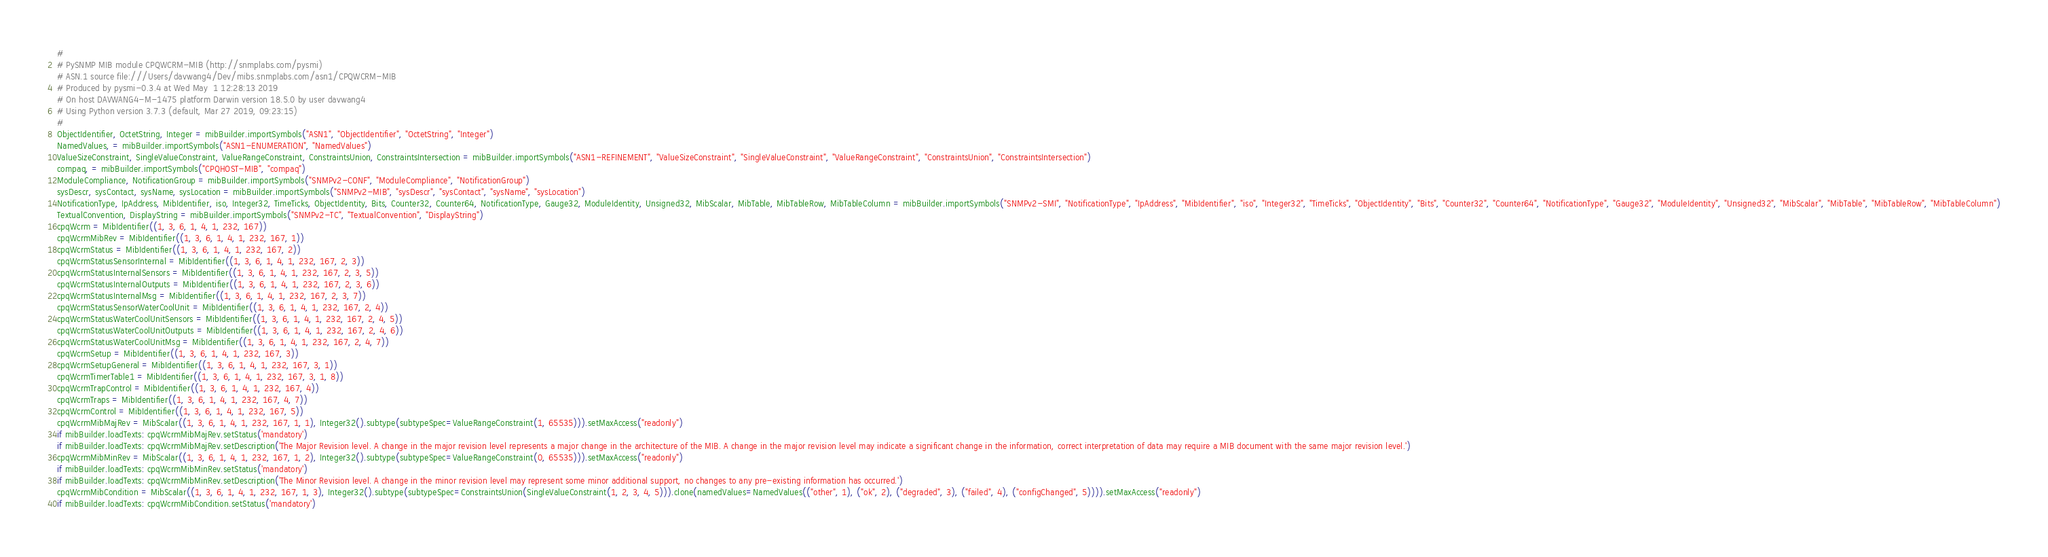<code> <loc_0><loc_0><loc_500><loc_500><_Python_>#
# PySNMP MIB module CPQWCRM-MIB (http://snmplabs.com/pysmi)
# ASN.1 source file:///Users/davwang4/Dev/mibs.snmplabs.com/asn1/CPQWCRM-MIB
# Produced by pysmi-0.3.4 at Wed May  1 12:28:13 2019
# On host DAVWANG4-M-1475 platform Darwin version 18.5.0 by user davwang4
# Using Python version 3.7.3 (default, Mar 27 2019, 09:23:15) 
#
ObjectIdentifier, OctetString, Integer = mibBuilder.importSymbols("ASN1", "ObjectIdentifier", "OctetString", "Integer")
NamedValues, = mibBuilder.importSymbols("ASN1-ENUMERATION", "NamedValues")
ValueSizeConstraint, SingleValueConstraint, ValueRangeConstraint, ConstraintsUnion, ConstraintsIntersection = mibBuilder.importSymbols("ASN1-REFINEMENT", "ValueSizeConstraint", "SingleValueConstraint", "ValueRangeConstraint", "ConstraintsUnion", "ConstraintsIntersection")
compaq, = mibBuilder.importSymbols("CPQHOST-MIB", "compaq")
ModuleCompliance, NotificationGroup = mibBuilder.importSymbols("SNMPv2-CONF", "ModuleCompliance", "NotificationGroup")
sysDescr, sysContact, sysName, sysLocation = mibBuilder.importSymbols("SNMPv2-MIB", "sysDescr", "sysContact", "sysName", "sysLocation")
NotificationType, IpAddress, MibIdentifier, iso, Integer32, TimeTicks, ObjectIdentity, Bits, Counter32, Counter64, NotificationType, Gauge32, ModuleIdentity, Unsigned32, MibScalar, MibTable, MibTableRow, MibTableColumn = mibBuilder.importSymbols("SNMPv2-SMI", "NotificationType", "IpAddress", "MibIdentifier", "iso", "Integer32", "TimeTicks", "ObjectIdentity", "Bits", "Counter32", "Counter64", "NotificationType", "Gauge32", "ModuleIdentity", "Unsigned32", "MibScalar", "MibTable", "MibTableRow", "MibTableColumn")
TextualConvention, DisplayString = mibBuilder.importSymbols("SNMPv2-TC", "TextualConvention", "DisplayString")
cpqWcrm = MibIdentifier((1, 3, 6, 1, 4, 1, 232, 167))
cpqWcrmMibRev = MibIdentifier((1, 3, 6, 1, 4, 1, 232, 167, 1))
cpqWcrmStatus = MibIdentifier((1, 3, 6, 1, 4, 1, 232, 167, 2))
cpqWcrmStatusSensorInternal = MibIdentifier((1, 3, 6, 1, 4, 1, 232, 167, 2, 3))
cpqWcrmStatusInternalSensors = MibIdentifier((1, 3, 6, 1, 4, 1, 232, 167, 2, 3, 5))
cpqWcrmStatusInternalOutputs = MibIdentifier((1, 3, 6, 1, 4, 1, 232, 167, 2, 3, 6))
cpqWcrmStatusInternalMsg = MibIdentifier((1, 3, 6, 1, 4, 1, 232, 167, 2, 3, 7))
cpqWcrmStatusSensorWaterCoolUnit = MibIdentifier((1, 3, 6, 1, 4, 1, 232, 167, 2, 4))
cpqWcrmStatusWaterCoolUnitSensors = MibIdentifier((1, 3, 6, 1, 4, 1, 232, 167, 2, 4, 5))
cpqWcrmStatusWaterCoolUnitOutputs = MibIdentifier((1, 3, 6, 1, 4, 1, 232, 167, 2, 4, 6))
cpqWcrmStatusWaterCoolUnitMsg = MibIdentifier((1, 3, 6, 1, 4, 1, 232, 167, 2, 4, 7))
cpqWcrmSetup = MibIdentifier((1, 3, 6, 1, 4, 1, 232, 167, 3))
cpqWcrmSetupGeneral = MibIdentifier((1, 3, 6, 1, 4, 1, 232, 167, 3, 1))
cpqWcrmTimerTable1 = MibIdentifier((1, 3, 6, 1, 4, 1, 232, 167, 3, 1, 8))
cpqWcrmTrapControl = MibIdentifier((1, 3, 6, 1, 4, 1, 232, 167, 4))
cpqWcrmTraps = MibIdentifier((1, 3, 6, 1, 4, 1, 232, 167, 4, 7))
cpqWcrmControl = MibIdentifier((1, 3, 6, 1, 4, 1, 232, 167, 5))
cpqWcrmMibMajRev = MibScalar((1, 3, 6, 1, 4, 1, 232, 167, 1, 1), Integer32().subtype(subtypeSpec=ValueRangeConstraint(1, 65535))).setMaxAccess("readonly")
if mibBuilder.loadTexts: cpqWcrmMibMajRev.setStatus('mandatory')
if mibBuilder.loadTexts: cpqWcrmMibMajRev.setDescription('The Major Revision level. A change in the major revision level represents a major change in the architecture of the MIB. A change in the major revision level may indicate a significant change in the information, correct interpretation of data may require a MIB document with the same major revision level.')
cpqWcrmMibMinRev = MibScalar((1, 3, 6, 1, 4, 1, 232, 167, 1, 2), Integer32().subtype(subtypeSpec=ValueRangeConstraint(0, 65535))).setMaxAccess("readonly")
if mibBuilder.loadTexts: cpqWcrmMibMinRev.setStatus('mandatory')
if mibBuilder.loadTexts: cpqWcrmMibMinRev.setDescription('The Minor Revision level. A change in the minor revision level may represent some minor additional support, no changes to any pre-existing information has occurred.')
cpqWcrmMibCondition = MibScalar((1, 3, 6, 1, 4, 1, 232, 167, 1, 3), Integer32().subtype(subtypeSpec=ConstraintsUnion(SingleValueConstraint(1, 2, 3, 4, 5))).clone(namedValues=NamedValues(("other", 1), ("ok", 2), ("degraded", 3), ("failed", 4), ("configChanged", 5)))).setMaxAccess("readonly")
if mibBuilder.loadTexts: cpqWcrmMibCondition.setStatus('mandatory')</code> 